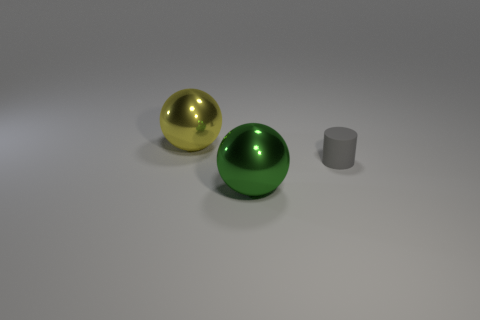Are there any metallic objects behind the rubber cylinder?
Ensure brevity in your answer.  Yes. What color is the other metal ball that is the same size as the yellow ball?
Offer a very short reply. Green. What number of yellow balls have the same material as the small gray object?
Provide a succinct answer. 0. What number of other objects are the same size as the gray thing?
Make the answer very short. 0. Are there any green shiny things of the same size as the rubber thing?
Give a very brief answer. No. What number of objects are yellow objects or cyan metallic cylinders?
Offer a very short reply. 1. Do the shiny sphere that is to the left of the green metallic thing and the tiny gray object have the same size?
Your response must be concise. No. What is the size of the thing that is both in front of the yellow object and behind the green metal sphere?
Your response must be concise. Small. How many other things are the same shape as the green metallic object?
Make the answer very short. 1. How many other objects are the same material as the gray thing?
Make the answer very short. 0. 